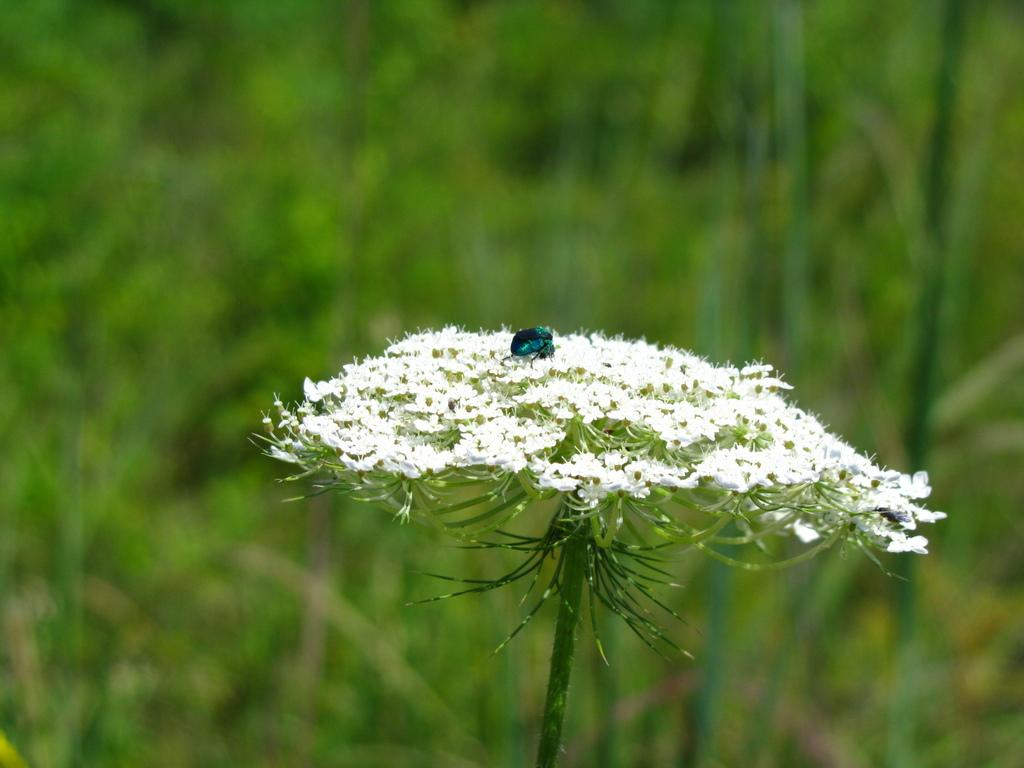What type of living organisms can be seen on the plant in the image? There are flowers on a plant in the image, and there is an insect on the plant. What can be observed about the background of the image? The background of the image is blurred. What type of cheese is being served on the plate in the image? There is no plate or cheese present in the image; it features flowers on a plant and an insect. What event is about to start in the image? There is no event or indication of a start in the image; it focuses on the plant and its inhabitants. 